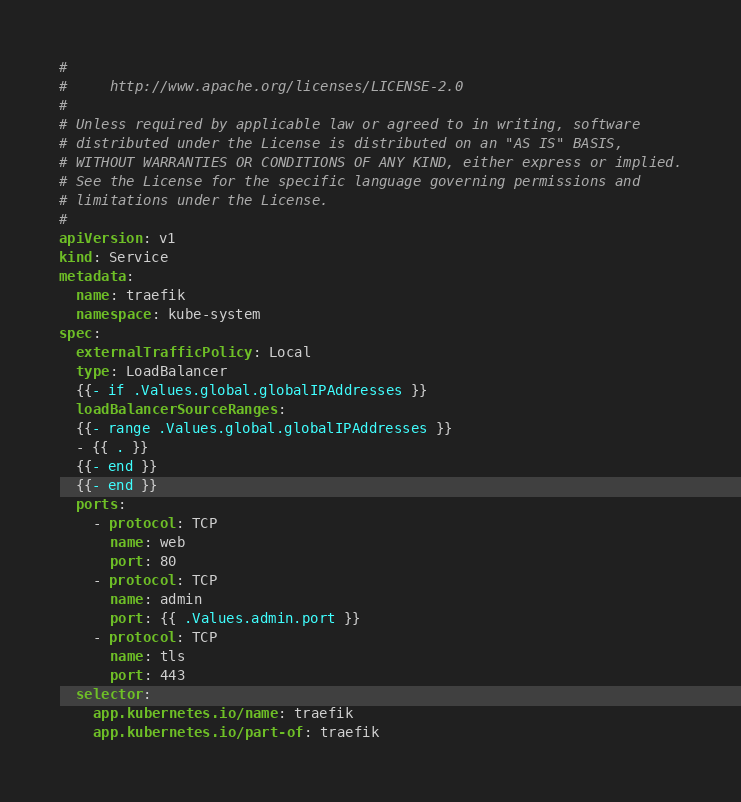Convert code to text. <code><loc_0><loc_0><loc_500><loc_500><_YAML_>#
#     http://www.apache.org/licenses/LICENSE-2.0
#
# Unless required by applicable law or agreed to in writing, software
# distributed under the License is distributed on an "AS IS" BASIS,
# WITHOUT WARRANTIES OR CONDITIONS OF ANY KIND, either express or implied.
# See the License for the specific language governing permissions and
# limitations under the License.
#
apiVersion: v1
kind: Service
metadata:
  name: traefik
  namespace: kube-system
spec:
  externalTrafficPolicy: Local
  type: LoadBalancer
  {{- if .Values.global.globalIPAddresses }}
  loadBalancerSourceRanges:
  {{- range .Values.global.globalIPAddresses }}
  - {{ . }}
  {{- end }}
  {{- end }}
  ports:
    - protocol: TCP
      name: web
      port: 80
    - protocol: TCP
      name: admin
      port: {{ .Values.admin.port }}
    - protocol: TCP
      name: tls
      port: 443
  selector:
    app.kubernetes.io/name: traefik
    app.kubernetes.io/part-of: traefik
</code> 